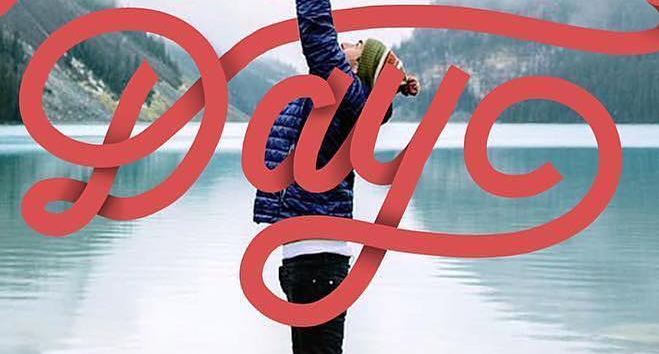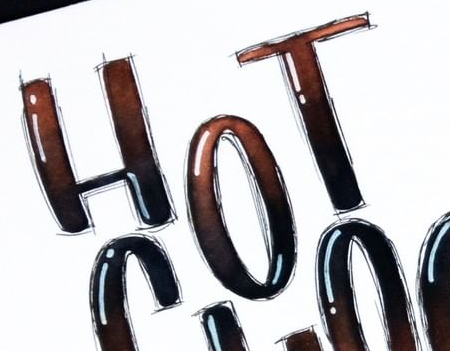Identify the words shown in these images in order, separated by a semicolon. Day; HOT 